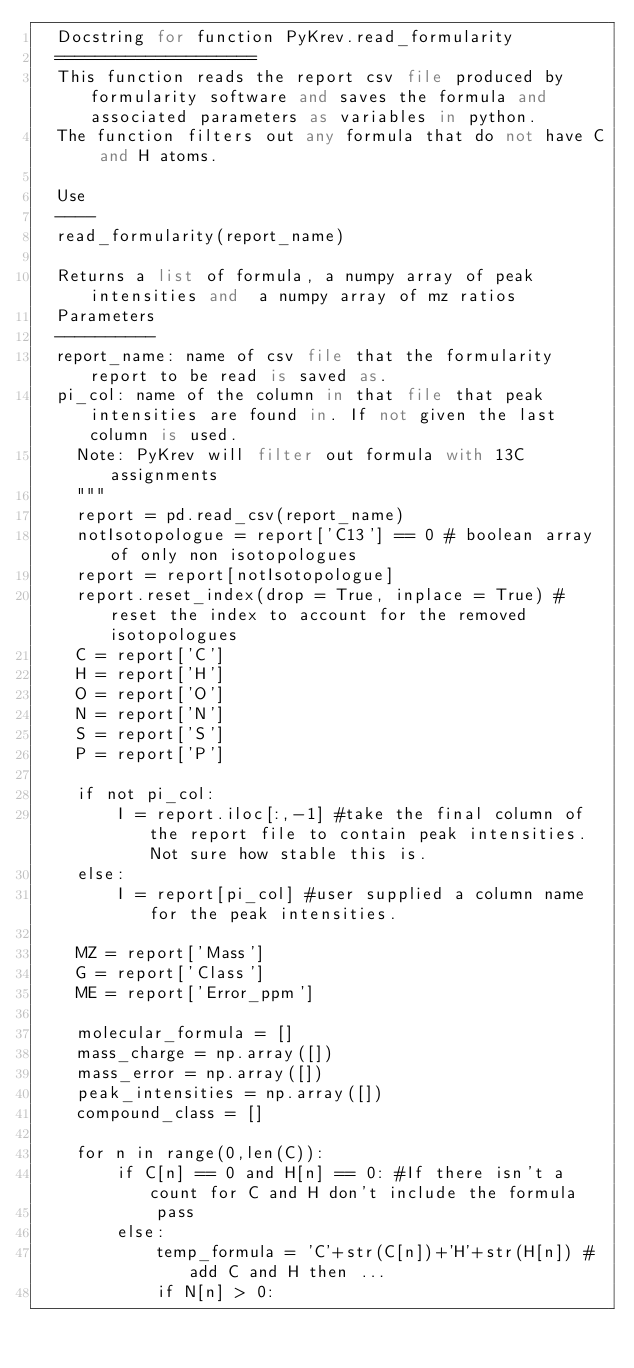<code> <loc_0><loc_0><loc_500><loc_500><_Python_>	Docstring for function PyKrev.read_formularity
	====================
	This function reads the report csv file produced by formularity software and saves the formula and associated parameters as variables in python. 
	The function filters out any formula that do not have C and H atoms.
    
	Use
	----
	read_formularity(report_name)
    
	Returns a list of formula, a numpy array of peak intensities and  a numpy array of mz ratios 
	Parameters
	----------
	report_name: name of csv file that the formularity report to be read is saved as. 
	pi_col: name of the column in that file that peak intensities are found in. If not given the last column is used. 
    Note: PyKrev will filter out formula with 13C assignments
    """
    report = pd.read_csv(report_name)
    notIsotopologue = report['C13'] == 0 # boolean array of only non isotopologues
    report = report[notIsotopologue]
    report.reset_index(drop = True, inplace = True) #reset the index to account for the removed isotopologues
    C = report['C']
    H = report['H']
    O = report['O']
    N = report['N'] 
    S = report['S']
    P = report['P']

    if not pi_col: 
        I = report.iloc[:,-1] #take the final column of the report file to contain peak intensities. Not sure how stable this is.
    else:
        I = report[pi_col] #user supplied a column name for the peak intensities.
    
    MZ = report['Mass']
    G = report['Class']
    ME = report['Error_ppm']

    molecular_formula = []
    mass_charge = np.array([])
    mass_error = np.array([])
    peak_intensities = np.array([])
    compound_class = []
    
    for n in range(0,len(C)):
        if C[n] == 0 and H[n] == 0: #If there isn't a count for C and H don't include the formula
            pass
        else:
            temp_formula = 'C'+str(C[n])+'H'+str(H[n]) #add C and H then ... 
            if N[n] > 0:</code> 